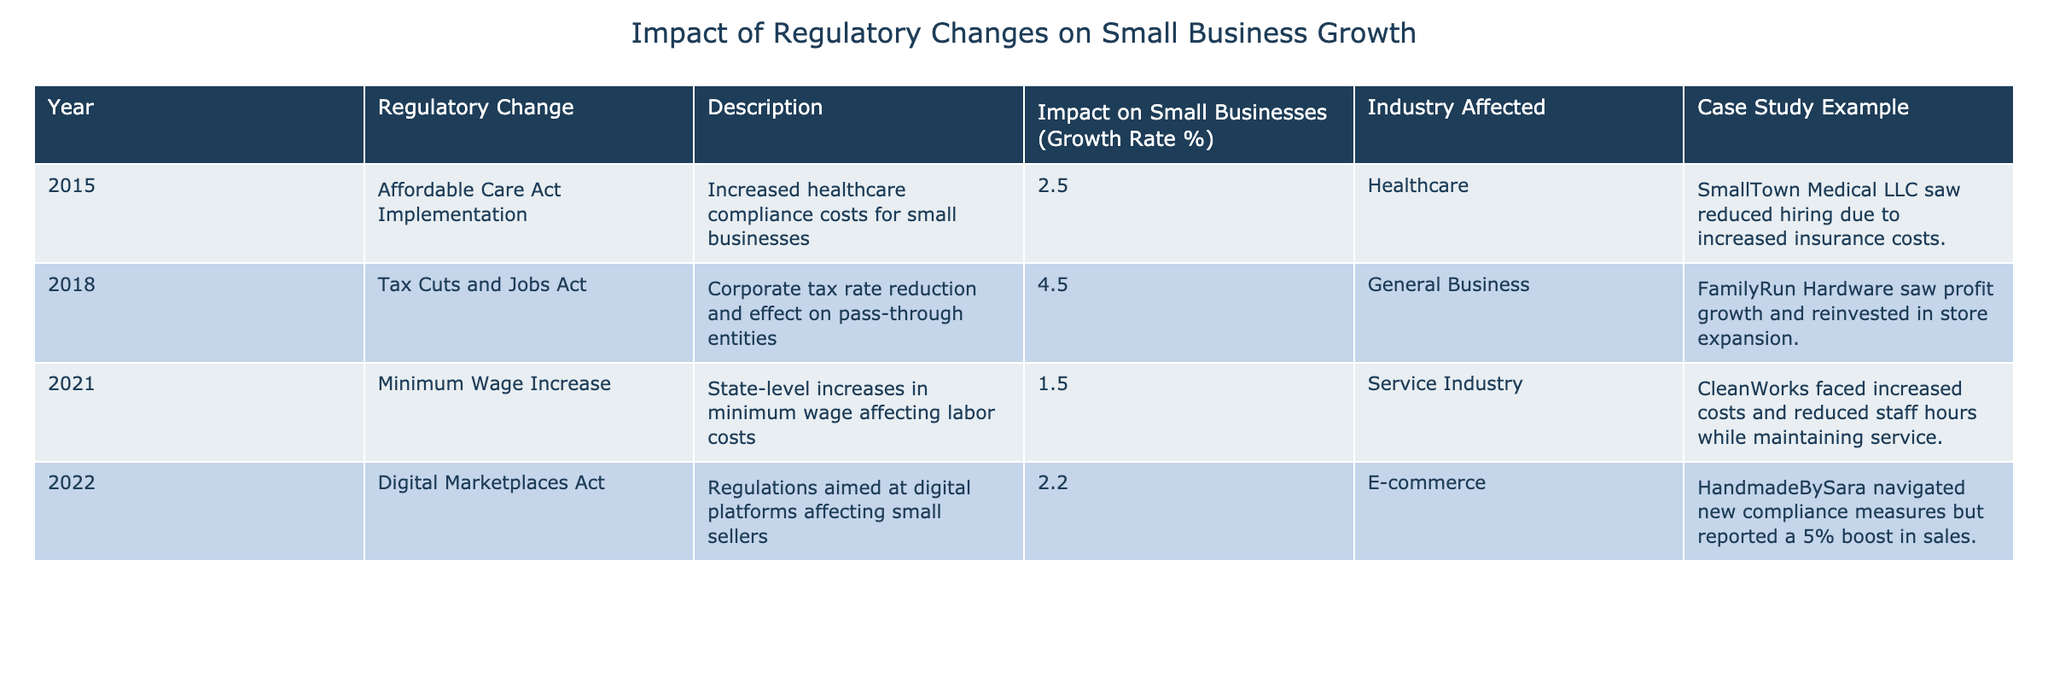What was the impact on small business growth in 2015? According to the table, the impact on small business growth in 2015 was 2.5%.
Answer: 2.5% Which regulatory change had the highest growth rate impact on small businesses? The Tax Cuts and Jobs Act in 2018 had the highest growth rate impact at 4.5%.
Answer: 4.5% Did the Minimum Wage Increase in 2021 positively impact small businesses? Based on the data, the Minimum Wage Increase had a growth rate impact of 1.5%, which indicates a negative or minimal impact.
Answer: No How many regulatory changes had an impact greater than 2%? From the table, there were three regulatory changes (Affordable Care Act Implementation, Tax Cuts and Jobs Act, Digital Marketplaces Act) that had impacts greater than 2%.
Answer: 3 What is the average impact on small businesses growth from all the listed regulatory changes? By adding the growth rates (2.5 + 4.5 + 1.5 + 2.2 = 10.7) and dividing by the number of changes (4), the average impact is 2.675%.
Answer: 2.675% Which industry was affected the most regarding the impact on small businesses? The industry with the highest reported growth rate impact is General Business, which had an impact of 4.5% from the Tax Cuts and Jobs Act.
Answer: General Business In which year did a case study example report a boost in sales despite new regulations? The case study example regarding HandmadeBySara reported a 5% boost in sales in 2022 after navigating new compliance measures.
Answer: 2022 Was there a regulatory change that reported reduced hiring due to compliance costs? Yes, the Affordable Care Act Implementation in 2015 reported reduced hiring due to increased insurance costs.
Answer: Yes 